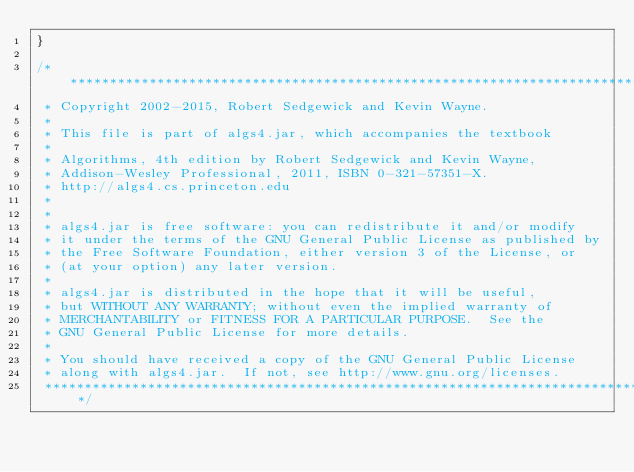<code> <loc_0><loc_0><loc_500><loc_500><_Java_>}

/******************************************************************************
 * Copyright 2002-2015, Robert Sedgewick and Kevin Wayne.
 *
 * This file is part of algs4.jar, which accompanies the textbook
 *
 * Algorithms, 4th edition by Robert Sedgewick and Kevin Wayne,
 * Addison-Wesley Professional, 2011, ISBN 0-321-57351-X.
 * http://algs4.cs.princeton.edu
 *
 *
 * algs4.jar is free software: you can redistribute it and/or modify
 * it under the terms of the GNU General Public License as published by
 * the Free Software Foundation, either version 3 of the License, or
 * (at your option) any later version.
 *
 * algs4.jar is distributed in the hope that it will be useful,
 * but WITHOUT ANY WARRANTY; without even the implied warranty of
 * MERCHANTABILITY or FITNESS FOR A PARTICULAR PURPOSE.  See the
 * GNU General Public License for more details.
 *
 * You should have received a copy of the GNU General Public License
 * along with algs4.jar.  If not, see http://www.gnu.org/licenses.
 ******************************************************************************/
</code> 